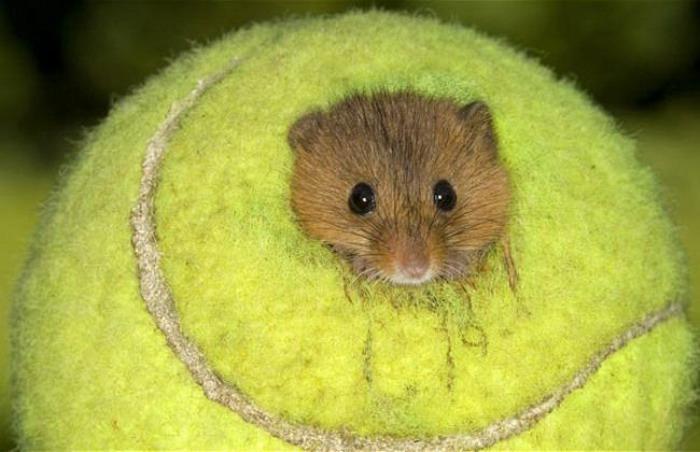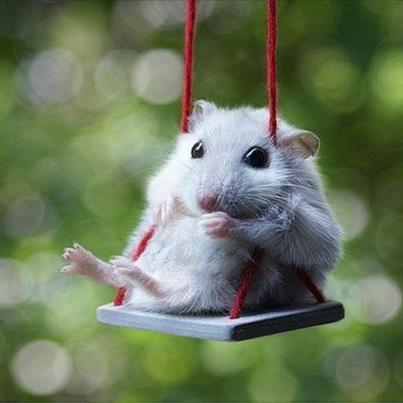The first image is the image on the left, the second image is the image on the right. For the images displayed, is the sentence "A small rodent is holding a tennis racket." factually correct? Answer yes or no. No. The first image is the image on the left, the second image is the image on the right. Analyze the images presented: Is the assertion "There is a hamster holding a tennis racket." valid? Answer yes or no. No. 